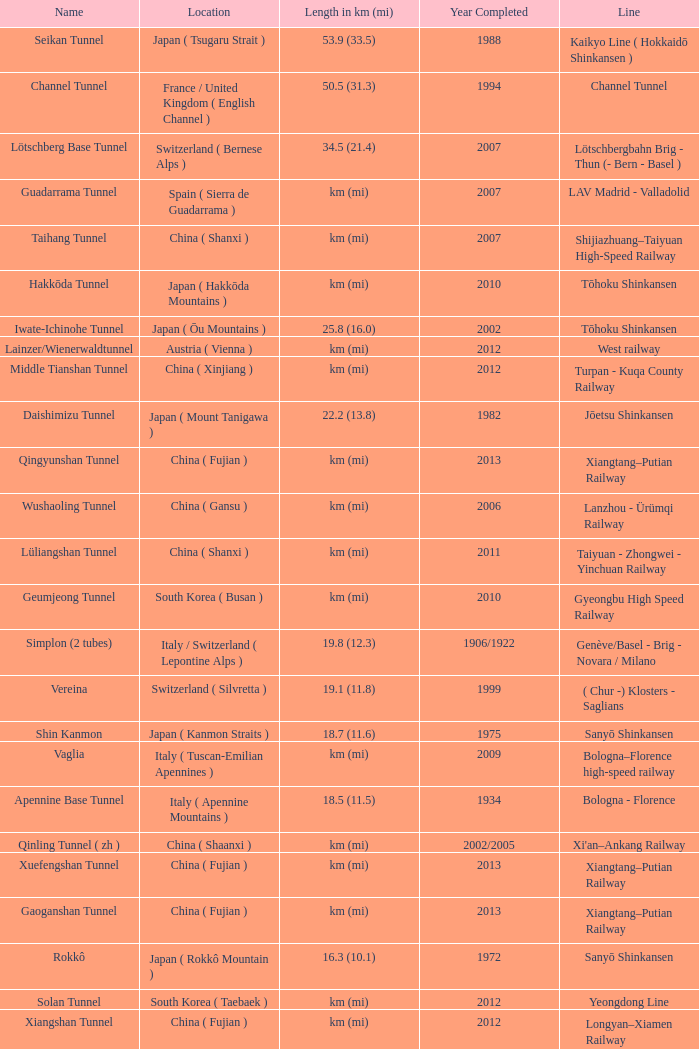Could you parse the entire table as a dict? {'header': ['Name', 'Location', 'Length in km (mi)', 'Year Completed', 'Line'], 'rows': [['Seikan Tunnel', 'Japan ( Tsugaru Strait )', '53.9 (33.5)', '1988', 'Kaikyo Line ( Hokkaidō Shinkansen )'], ['Channel Tunnel', 'France / United Kingdom ( English Channel )', '50.5 (31.3)', '1994', 'Channel Tunnel'], ['Lötschberg Base Tunnel', 'Switzerland ( Bernese Alps )', '34.5 (21.4)', '2007', 'Lötschbergbahn Brig - Thun (- Bern - Basel )'], ['Guadarrama Tunnel', 'Spain ( Sierra de Guadarrama )', 'km (mi)', '2007', 'LAV Madrid - Valladolid'], ['Taihang Tunnel', 'China ( Shanxi )', 'km (mi)', '2007', 'Shijiazhuang–Taiyuan High-Speed Railway'], ['Hakkōda Tunnel', 'Japan ( Hakkōda Mountains )', 'km (mi)', '2010', 'Tōhoku Shinkansen'], ['Iwate-Ichinohe Tunnel', 'Japan ( Ōu Mountains )', '25.8 (16.0)', '2002', 'Tōhoku Shinkansen'], ['Lainzer/Wienerwaldtunnel', 'Austria ( Vienna )', 'km (mi)', '2012', 'West railway'], ['Middle Tianshan Tunnel', 'China ( Xinjiang )', 'km (mi)', '2012', 'Turpan - Kuqa County Railway'], ['Daishimizu Tunnel', 'Japan ( Mount Tanigawa )', '22.2 (13.8)', '1982', 'Jōetsu Shinkansen'], ['Qingyunshan Tunnel', 'China ( Fujian )', 'km (mi)', '2013', 'Xiangtang–Putian Railway'], ['Wushaoling Tunnel', 'China ( Gansu )', 'km (mi)', '2006', 'Lanzhou - Ürümqi Railway'], ['Lüliangshan Tunnel', 'China ( Shanxi )', 'km (mi)', '2011', 'Taiyuan - Zhongwei - Yinchuan Railway'], ['Geumjeong Tunnel', 'South Korea ( Busan )', 'km (mi)', '2010', 'Gyeongbu High Speed Railway'], ['Simplon (2 tubes)', 'Italy / Switzerland ( Lepontine Alps )', '19.8 (12.3)', '1906/1922', 'Genève/Basel - Brig - Novara / Milano'], ['Vereina', 'Switzerland ( Silvretta )', '19.1 (11.8)', '1999', '( Chur -) Klosters - Saglians'], ['Shin Kanmon', 'Japan ( Kanmon Straits )', '18.7 (11.6)', '1975', 'Sanyō Shinkansen'], ['Vaglia', 'Italy ( Tuscan-Emilian Apennines )', 'km (mi)', '2009', 'Bologna–Florence high-speed railway'], ['Apennine Base Tunnel', 'Italy ( Apennine Mountains )', '18.5 (11.5)', '1934', 'Bologna - Florence'], ['Qinling Tunnel ( zh )', 'China ( Shaanxi )', 'km (mi)', '2002/2005', "Xi'an–Ankang Railway"], ['Xuefengshan Tunnel', 'China ( Fujian )', 'km (mi)', '2013', 'Xiangtang–Putian Railway'], ['Gaoganshan Tunnel', 'China ( Fujian )', 'km (mi)', '2013', 'Xiangtang–Putian Railway'], ['Rokkô', 'Japan ( Rokkô Mountain )', '16.3 (10.1)', '1972', 'Sanyō Shinkansen'], ['Solan Tunnel', 'South Korea ( Taebaek )', 'km (mi)', '2012', 'Yeongdong Line'], ['Xiangshan Tunnel', 'China ( Fujian )', 'km (mi)', '2012', 'Longyan–Xiamen Railway'], ['Daiyunshan Tunnel', 'China ( Fujian )', 'km (mi)', '2013', 'Xiangtang–Putian Railway'], ['Guanshan Tunnel', 'China ( Gansu )', 'km (mi)', '2012', 'Tianshui - Pingliang Railway'], ['Furka Base', 'Switzerland ( Urner Alps )', '15.4 (9.6)', '1982', 'Andermatt - Brig'], ['Haruna', 'Japan ( Gunma Prefecture )', '15.4 (9.5)', '1982', 'Jōetsu Shinkansen'], ['Firenzuola', 'Italy ( Tuscan-Emilian Apennines )', 'km (mi)', '2009', 'Bologna–Florence high-speed railway'], ['Severomuyskiy', 'Russia ( Severomuysky Range )', '15.3 (9.5)', '2001', 'Baikal Amur Mainline'], ['Gorigamine', 'Japan ( Akaishi Mountains )', '15.2 (9.4)', '1997', 'Nagano Shinkansen ( Hokuriku Shinkansen )'], ['Liulangshan Tunnel', 'China ( Shanxi )', 'km (mi)', '2012', 'Zhungeer - Shuozhou Railway'], ['Monte Santomarco', 'Italy ( Sila Mountains )', '15.0 (9.3)', '1987', 'Paola - Cosenza'], ['Gotthard Rail Tunnel', 'Switzerland ( Lepontine Alps )', '15.0 (9.3)', '1882', 'Gotthardbahn Luzern / Zürich - Lugano - Milano'], ['Maotianshan Tunnel', 'China ( Shaanxi )', 'km (mi)', '2011', "Baotou - Xi'an Railway"], ['Nakayama', 'Japan ( Nakayama Pass )', '14.9 (9.2)', '1982', 'Jōetsu Shinkansen'], ['El Sargento #4', 'Peru', 'km (mi)', '1975', 'Tacna - Moquegua'], ['Mount Macdonald Tunnel', 'Canada ( Rogers Pass )', '14.7 (9.1)', '1989', 'Calgary - Revelstoke'], ['Wuyishan Tunnel', 'China ( Fujian )', 'km (mi)', '2013', 'Xiangtang–Putian Railway'], ['Lötschberg', 'Switzerland ( Bernese Alps )', '14.6 (9.1)', '1913', 'Lötschbergbahn Brig - Thun (- Bern - Basel )'], ['Romeriksporten', 'Norway ( Østmarka )', '14.6 (9.1)', '1999', 'Gardermobanen'], ['Dayaoshan Tunnel ( zh )', 'China ( Guangdong )', 'km (mi)', '1987', 'Beijing - Guangzhou Railway'], ['Jinguashan Tunnel', 'China ( Fujian )', 'km (mi)', '2013', 'Xiangtang–Putian Railway'], ['Hokuriku', 'Japan ( Mount Kinome )', '13.9 (8.6)', '1962', 'Hokuriku Main Line'], ['Yesanguan Tunnel', 'China ( Hubei )', 'km (mi)', '2009', 'Yichang - Wanzhou Railway'], ['North Tianshan Tunnel', 'China ( Xinjiang )', 'km (mi)', '2009', 'Jinhe - Yining - Huo Erguosi Railway'], ['Marmaray', 'Turkey ( Istanbul )', 'km (mi)', '2013', 'Marmaray'], ['Fréjus', 'France ( Mont Cenis )', '13.5 (8.4)', '1871', 'Lyon - Turin'], ['Epping to Chatswood RailLink', 'Australia ( Sydney )', '13.5 (8.4)', '2009', 'Epping - Chatswood'], ['Shin-Shimizu Tunnel', 'Japan ( Mount Tanigawa )', '13.5 (8.4)', '1967', 'Jōetsu Line'], ['Hex River', 'South Africa ( Hex River Pass )', 'km (mi)', '1989', 'Pretoria - Cape Town'], ['Savio Rail Tunnel', 'Finland ( Uusimaa )', 'km (mi)', '2008', 'Kerava - Vuosaari'], ['Wonhyo Tunnel', 'South Korea ( Ulsan )', 'km (mi)', '2010', 'Gyeongbu High Speed Railway'], ['Dabieshan Tunnel', 'China ( Hubei )', 'km (mi)', '2008', 'Hefei - Wuhan High Speed Railway'], ['Schlern/Sciliar', 'Italy ( South Tyrol )', '13.2 (8.2)', '1993', 'Brenner Railway'], ['Caponero-Capoverde', 'Italy', '13.1 (8.2)', '2001', 'Genova-Ventimiglia'], ['Aki', 'Japan', '13.0 (8.2)', '1975', 'Sanyo Shinkansen , Japan']]} Which line is the Geumjeong tunnel? Gyeongbu High Speed Railway. 